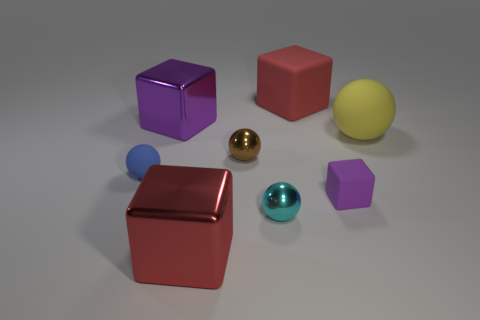There is a object that is behind the tiny matte sphere and to the right of the red matte block; what is its material?
Your response must be concise. Rubber. Is there another big shiny object of the same shape as the red metallic thing?
Provide a short and direct response. Yes. There is a big red rubber thing that is behind the blue sphere; what shape is it?
Provide a succinct answer. Cube. There is a purple thing behind the matte ball that is right of the red matte cube; how many purple objects are to the right of it?
Make the answer very short. 1. Does the big shiny cube that is behind the large matte ball have the same color as the tiny cube?
Make the answer very short. Yes. How many other objects are there of the same shape as the brown object?
Provide a short and direct response. 3. What number of other things are the same material as the big yellow ball?
Keep it short and to the point. 3. What is the material of the red cube that is in front of the large shiny thing behind the tiny matte object in front of the small blue ball?
Your response must be concise. Metal. Are the small block and the yellow object made of the same material?
Provide a short and direct response. Yes. What number of blocks are small blue things or purple things?
Keep it short and to the point. 2. 